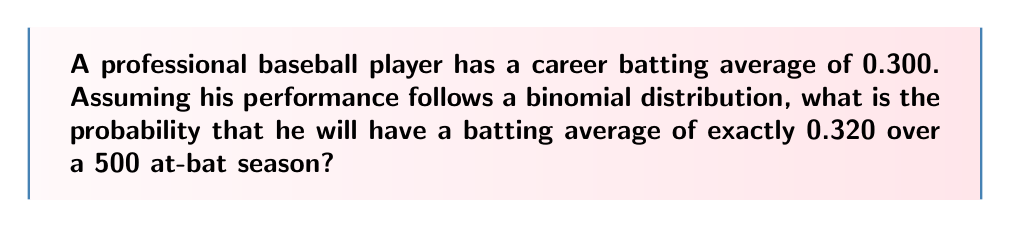Show me your answer to this math problem. To solve this problem, we need to use the binomial probability formula and consider the following steps:

1. Identify the parameters:
   - $n$ = number of trials (at-bats) = 500
   - $p$ = probability of success (career batting average) = 0.300
   - $k$ = number of successes (hits) for the desired batting average
   
2. Calculate $k$:
   For a batting average of 0.320 over 500 at-bats:
   $k = 500 \times 0.320 = 160$ hits

3. Use the binomial probability formula:
   $$P(X = k) = \binom{n}{k} p^k (1-p)^{n-k}$$

   Where $\binom{n}{k}$ is the binomial coefficient, calculated as:
   $$\binom{n}{k} = \frac{n!}{k!(n-k)!}$$

4. Substitute the values:
   $$P(X = 160) = \binom{500}{160} (0.300)^{160} (1-0.300)^{500-160}$$

5. Calculate:
   $$P(X = 160) = \frac{500!}{160!(500-160)!} (0.300)^{160} (0.700)^{340}$$

6. Use a calculator or computer to evaluate this expression, as the numbers are too large for manual calculation.

The result of this calculation gives us the probability of the player achieving exactly 160 hits in 500 at-bats, which corresponds to a 0.320 batting average for the season.
Answer: $P(X = 160) \approx 0.0183$ or about 1.83% 